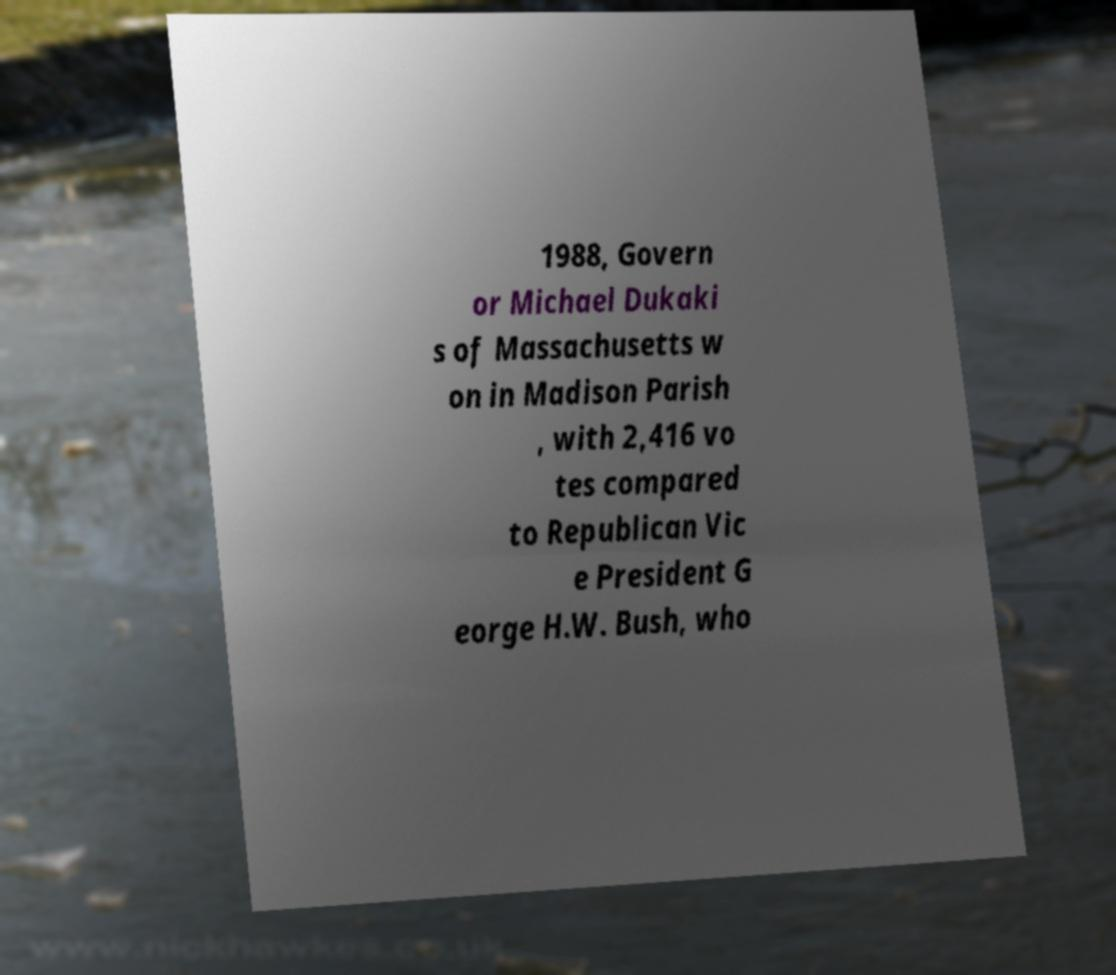Please identify and transcribe the text found in this image. 1988, Govern or Michael Dukaki s of Massachusetts w on in Madison Parish , with 2,416 vo tes compared to Republican Vic e President G eorge H.W. Bush, who 